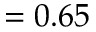<formula> <loc_0><loc_0><loc_500><loc_500>= 0 . 6 5</formula> 